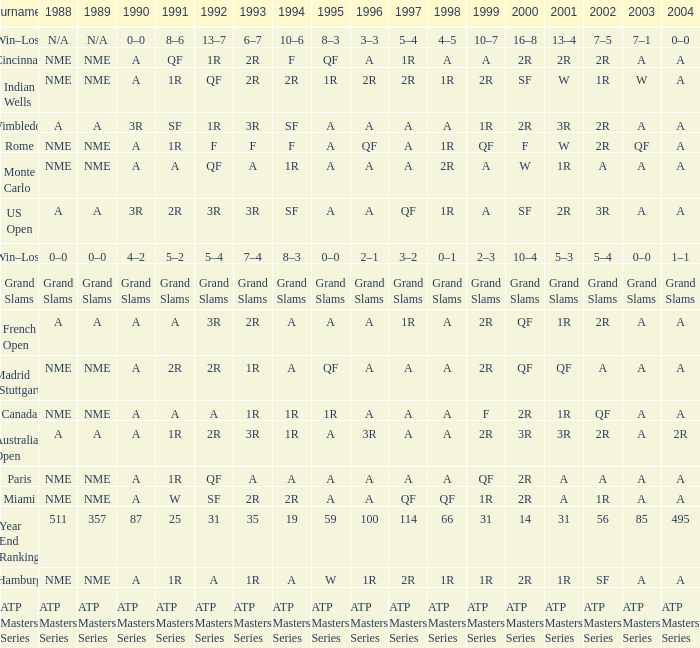What shows for 2002 when the 1991 is w? 1R. 